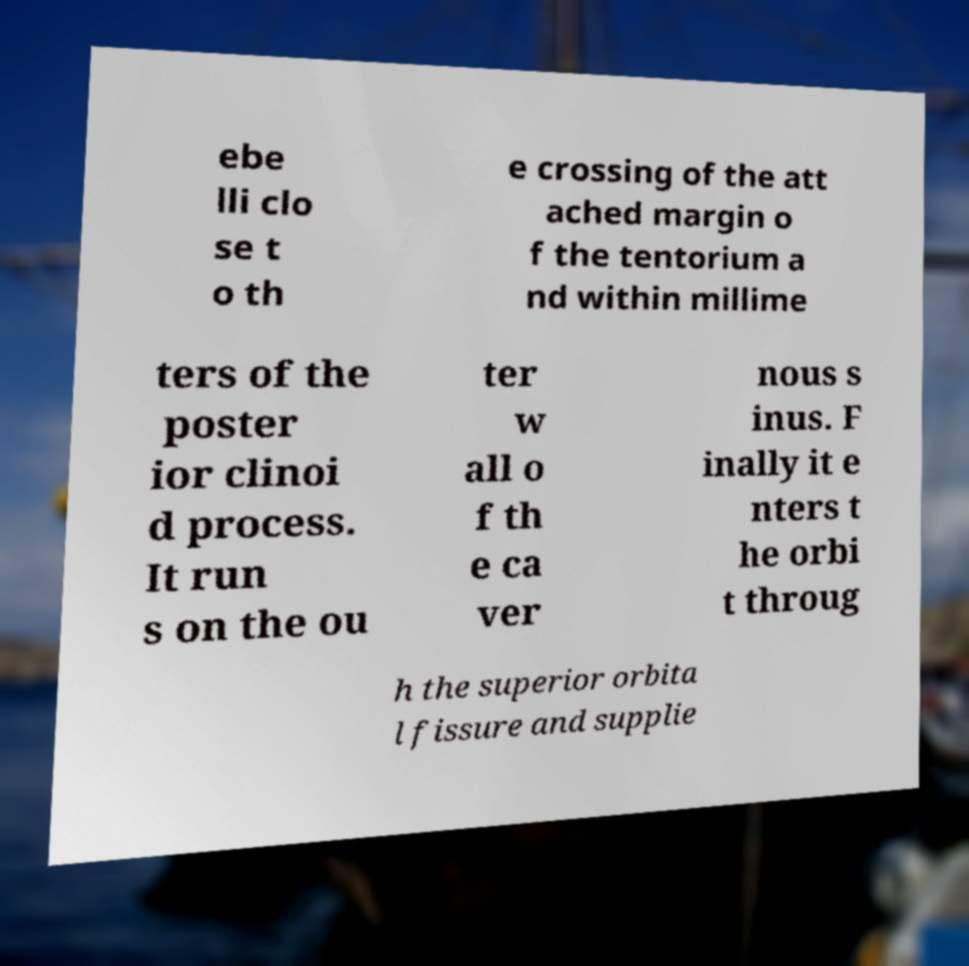There's text embedded in this image that I need extracted. Can you transcribe it verbatim? ebe lli clo se t o th e crossing of the att ached margin o f the tentorium a nd within millime ters of the poster ior clinoi d process. It run s on the ou ter w all o f th e ca ver nous s inus. F inally it e nters t he orbi t throug h the superior orbita l fissure and supplie 